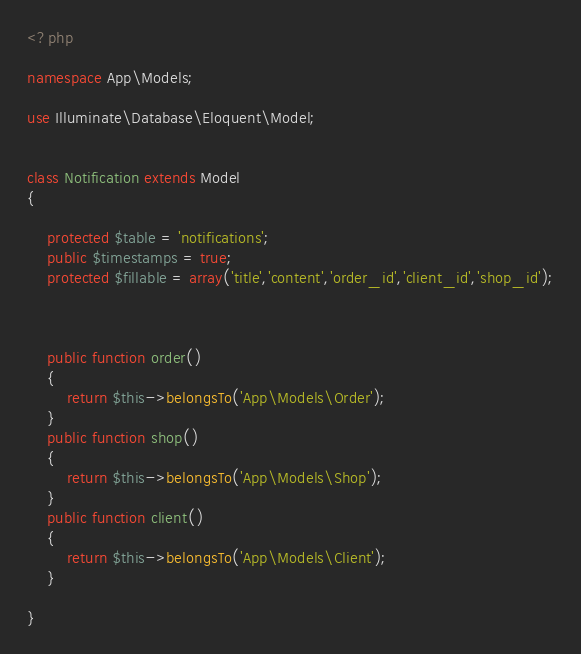<code> <loc_0><loc_0><loc_500><loc_500><_PHP_><?php

namespace App\Models;

use Illuminate\Database\Eloquent\Model;


class Notification extends Model
{
    
    protected $table = 'notifications';
    public $timestamps = true;
    protected $fillable = array('title','content','order_id','client_id','shop_id');
    


    public function order()
    {
        return $this->belongsTo('App\Models\Order');
    }
    public function shop()
    {
        return $this->belongsTo('App\Models\Shop');
    }
    public function client()
    {
        return $this->belongsTo('App\Models\Client');
    }

}</code> 